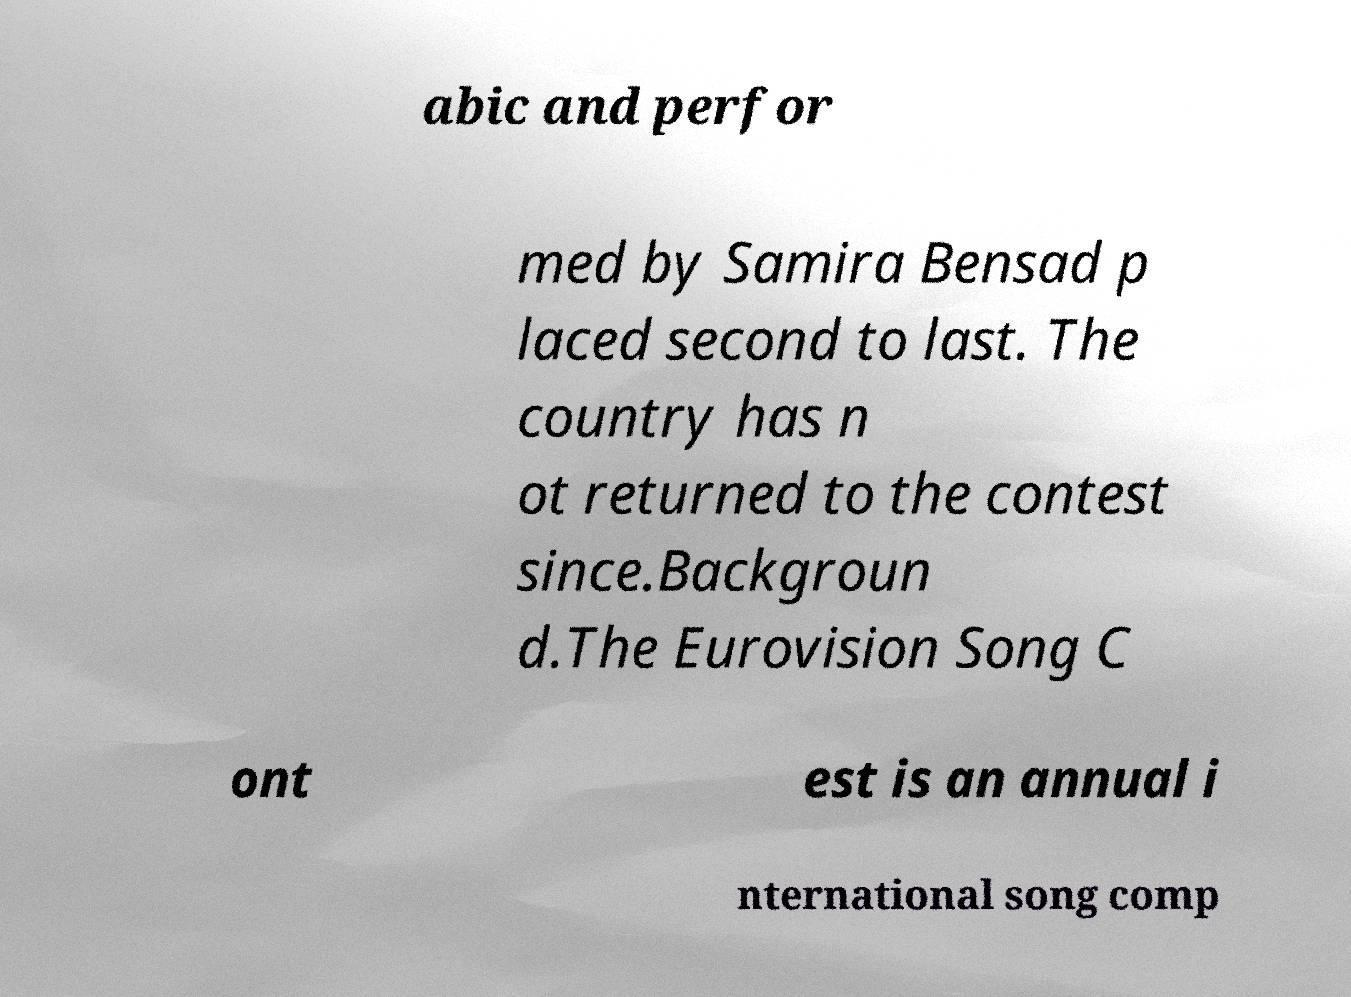There's text embedded in this image that I need extracted. Can you transcribe it verbatim? abic and perfor med by Samira Bensad p laced second to last. The country has n ot returned to the contest since.Backgroun d.The Eurovision Song C ont est is an annual i nternational song comp 